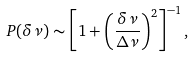<formula> <loc_0><loc_0><loc_500><loc_500>P ( \delta \nu ) \sim \left [ 1 + \left ( \frac { \delta \nu } { \Delta \nu } \right ) ^ { 2 } \right ] ^ { - 1 } ,</formula> 